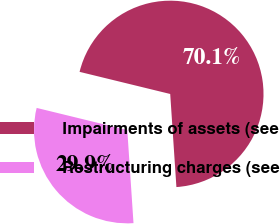Convert chart. <chart><loc_0><loc_0><loc_500><loc_500><pie_chart><fcel>Impairments of assets (see<fcel>Restructuring charges (see<nl><fcel>70.13%<fcel>29.87%<nl></chart> 